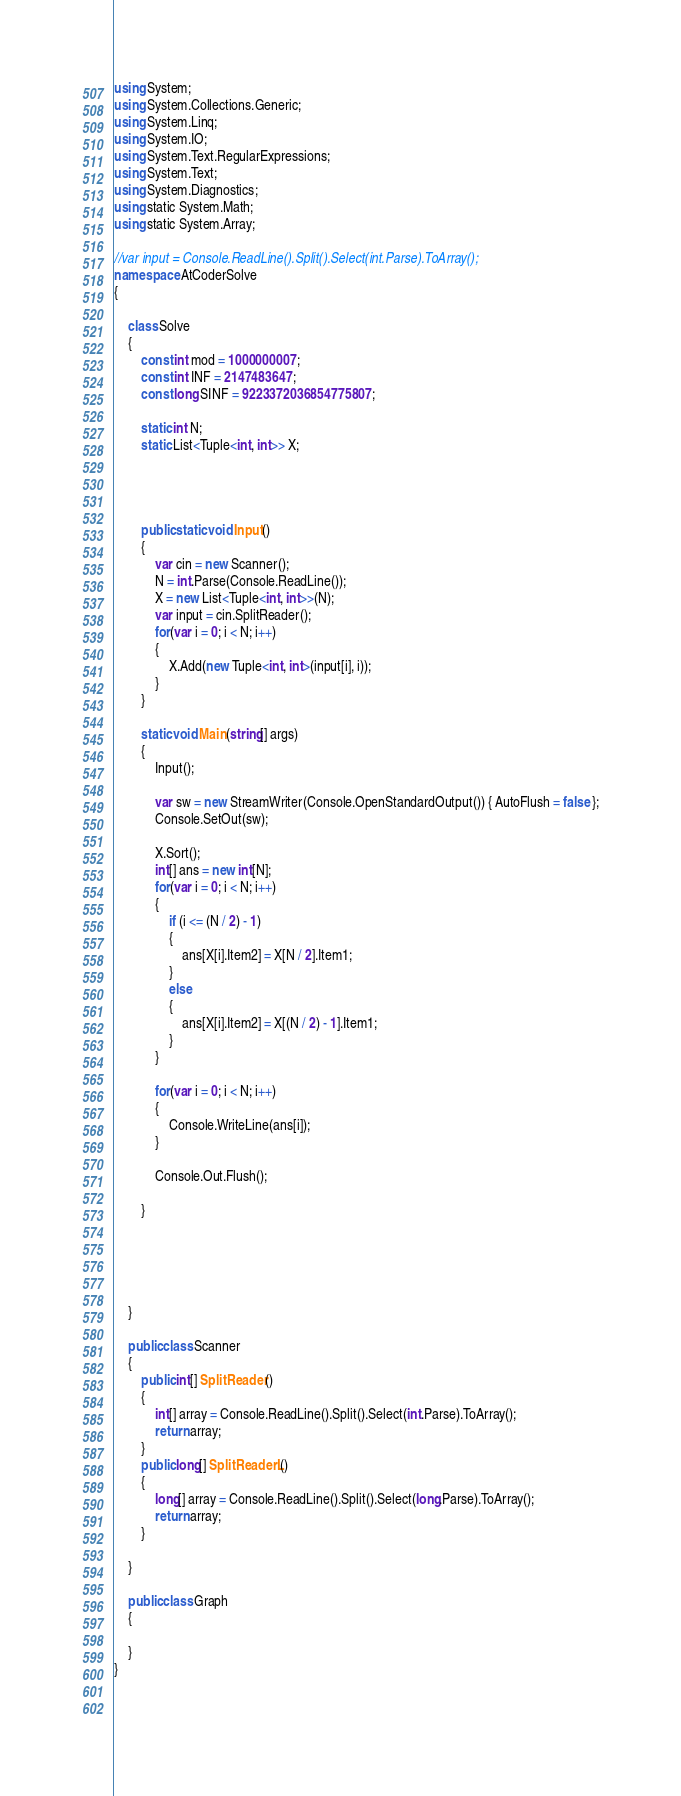Convert code to text. <code><loc_0><loc_0><loc_500><loc_500><_C#_>using System;
using System.Collections.Generic;
using System.Linq;
using System.IO;
using System.Text.RegularExpressions;
using System.Text;
using System.Diagnostics;
using static System.Math;
using static System.Array;

//var input = Console.ReadLine().Split().Select(int.Parse).ToArray();
namespace AtCoderSolve
{

    class Solve
    {
        const int mod = 1000000007;
        const int INF = 2147483647;
        const long SINF = 9223372036854775807;

        static int N;
        static List<Tuple<int, int>> X;
        
        
        

        public static void Input()
        {
            var cin = new Scanner();
            N = int.Parse(Console.ReadLine());
            X = new List<Tuple<int, int>>(N);
            var input = cin.SplitReader();
            for(var i = 0; i < N; i++)
            {
                X.Add(new Tuple<int, int>(input[i], i));
            }
        }

        static void Main(string[] args)
        {
            Input();

            var sw = new StreamWriter(Console.OpenStandardOutput()) { AutoFlush = false };
            Console.SetOut(sw);

            X.Sort();
            int[] ans = new int[N];
            for(var i = 0; i < N; i++)
            {
                if (i <= (N / 2) - 1)
                {
                    ans[X[i].Item2] = X[N / 2].Item1;
                }
                else
                {
                    ans[X[i].Item2] = X[(N / 2) - 1].Item1;
                }
            }

            for(var i = 0; i < N; i++)
            {
                Console.WriteLine(ans[i]);
            }

            Console.Out.Flush();

        }





    }

    public class Scanner
    {
        public int[] SplitReader()
        {
            int[] array = Console.ReadLine().Split().Select(int.Parse).ToArray();
            return array;
        }
        public long[] SplitReaderL()
        {
            long[] array = Console.ReadLine().Split().Select(long.Parse).ToArray();
            return array;
        }

    }

    public class Graph
    {
        
    }
}

    

</code> 